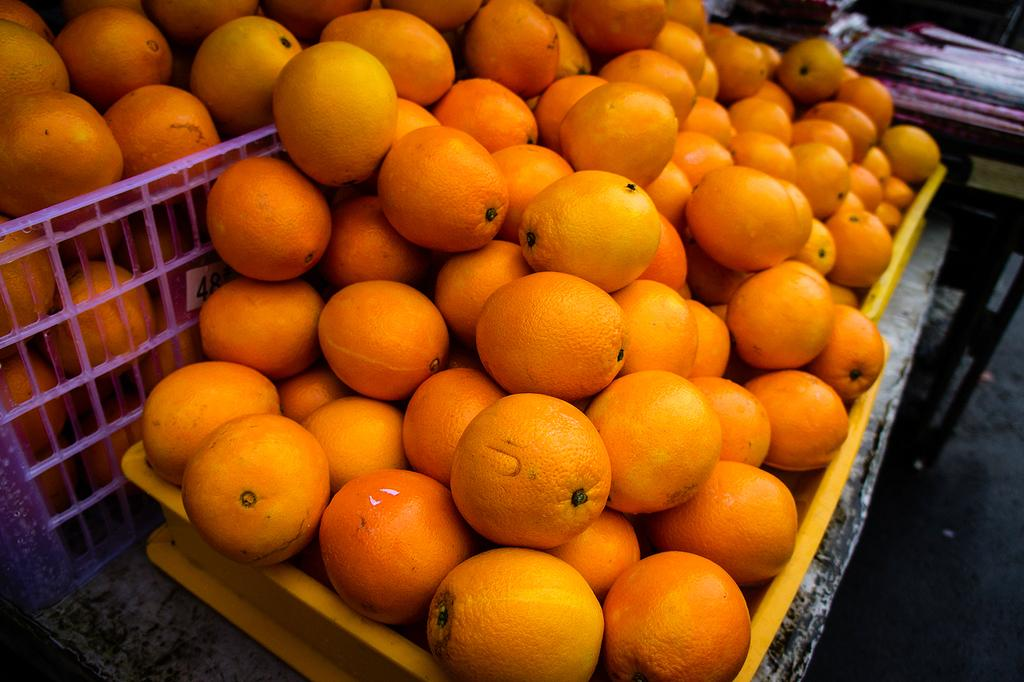What type of fruit is present in the image? There are oranges in the image. How are the oranges arranged or organized in the image? The oranges are placed in a basket. Can you see a snake slithering among the oranges in the image? No, there is no snake present in the image. 